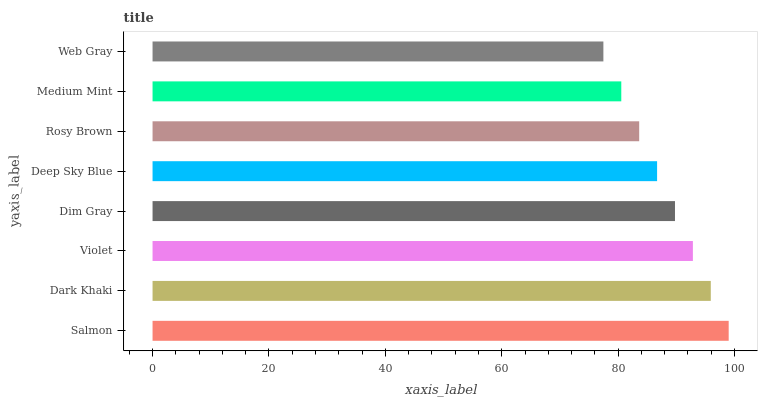Is Web Gray the minimum?
Answer yes or no. Yes. Is Salmon the maximum?
Answer yes or no. Yes. Is Dark Khaki the minimum?
Answer yes or no. No. Is Dark Khaki the maximum?
Answer yes or no. No. Is Salmon greater than Dark Khaki?
Answer yes or no. Yes. Is Dark Khaki less than Salmon?
Answer yes or no. Yes. Is Dark Khaki greater than Salmon?
Answer yes or no. No. Is Salmon less than Dark Khaki?
Answer yes or no. No. Is Dim Gray the high median?
Answer yes or no. Yes. Is Deep Sky Blue the low median?
Answer yes or no. Yes. Is Web Gray the high median?
Answer yes or no. No. Is Violet the low median?
Answer yes or no. No. 